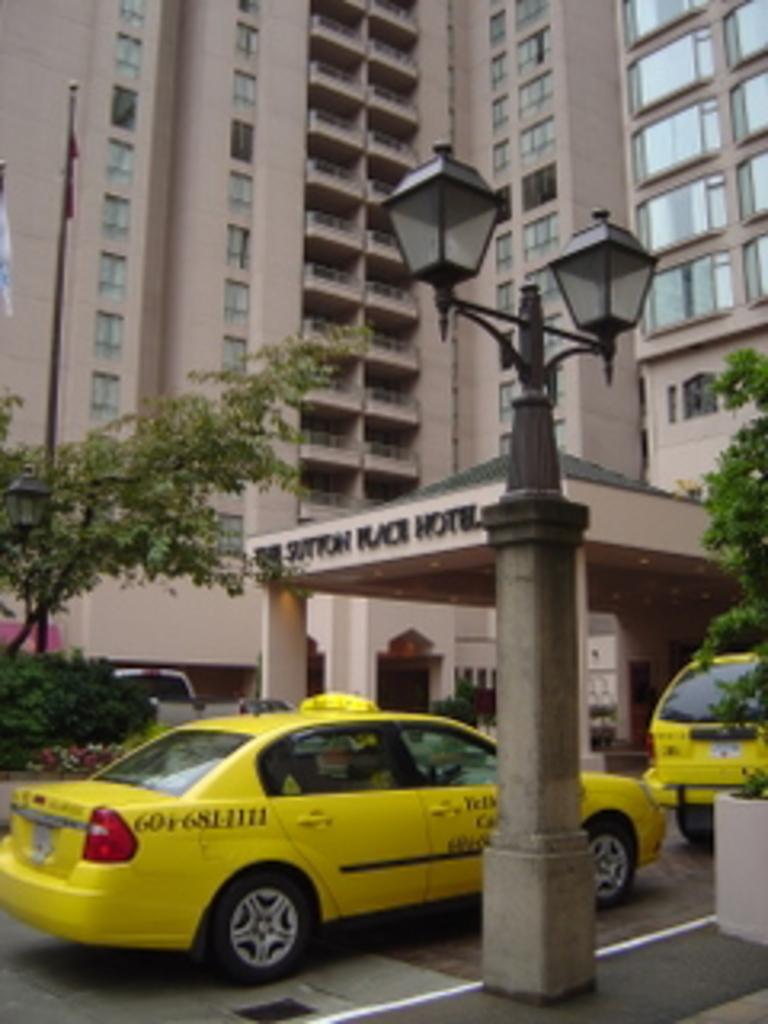What hotel is this?
Your response must be concise. Sutton place hotel. 